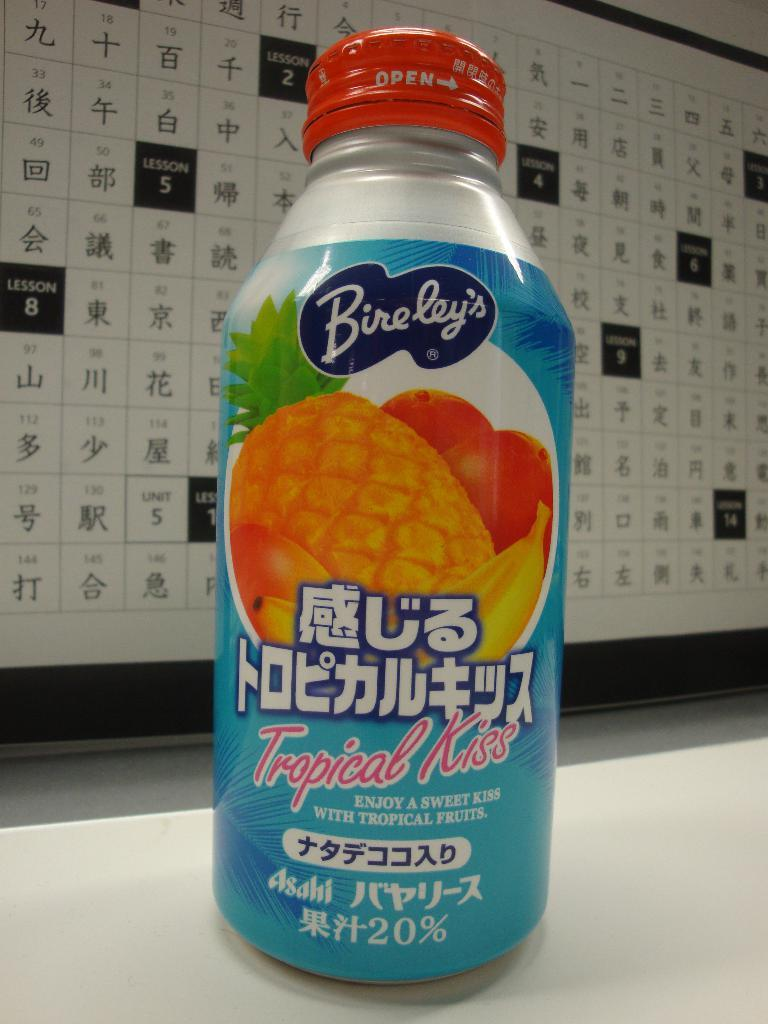What type of beverage container is visible in the image? There is a juice bottle in the image. What brand or label is on the juice bottle? The juice bottle has the label "Bireley's" on it. What type of calendar is hanging on the wall next to the juice bottle? There is no calendar present in the image; it only features a juice bottle with the label "Bireley's." 